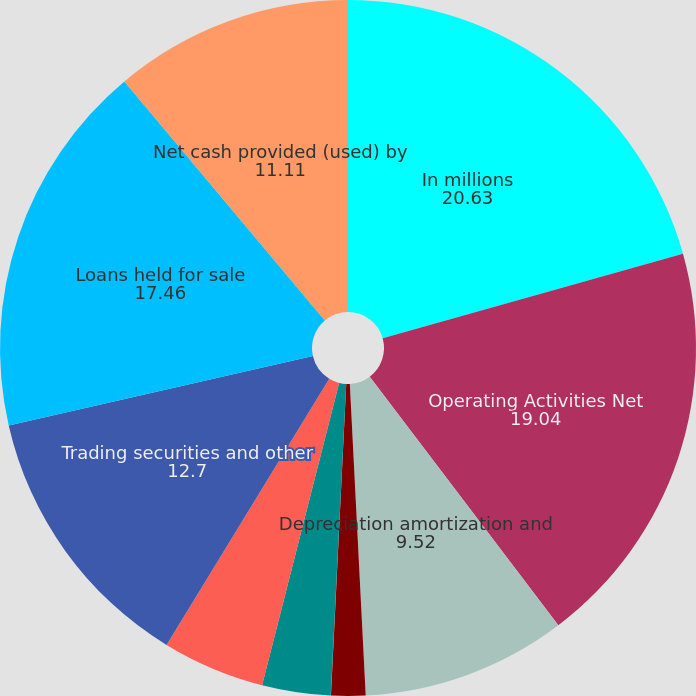Convert chart. <chart><loc_0><loc_0><loc_500><loc_500><pie_chart><fcel>In millions<fcel>Operating Activities Net<fcel>Depreciation amortization and<fcel>Deferred income taxes<fcel>Net securities losses<fcel>Net losses (gains) related to<fcel>Undistributed earnings of<fcel>Trading securities and other<fcel>Loans held for sale<fcel>Net cash provided (used) by<nl><fcel>20.63%<fcel>19.04%<fcel>9.52%<fcel>1.59%<fcel>0.01%<fcel>3.18%<fcel>4.76%<fcel>12.7%<fcel>17.46%<fcel>11.11%<nl></chart> 